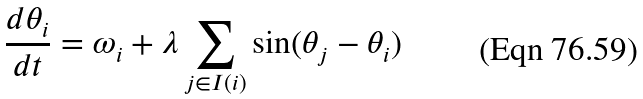Convert formula to latex. <formula><loc_0><loc_0><loc_500><loc_500>\frac { d \theta _ { i } } { d t } = \omega _ { i } + \lambda \sum _ { j \in I ( i ) } \sin ( \theta _ { j } - \theta _ { i } )</formula> 